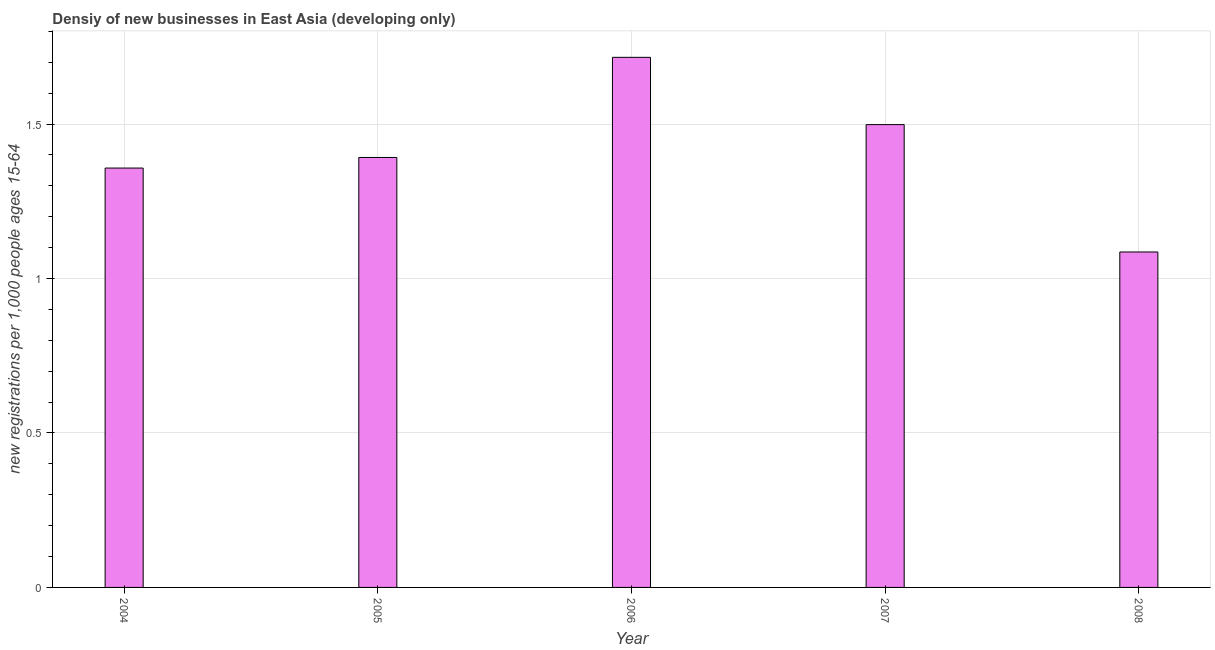Does the graph contain any zero values?
Offer a terse response. No. What is the title of the graph?
Ensure brevity in your answer.  Densiy of new businesses in East Asia (developing only). What is the label or title of the X-axis?
Give a very brief answer. Year. What is the label or title of the Y-axis?
Provide a succinct answer. New registrations per 1,0 people ages 15-64. What is the density of new business in 2004?
Your response must be concise. 1.36. Across all years, what is the maximum density of new business?
Your answer should be compact. 1.72. Across all years, what is the minimum density of new business?
Your response must be concise. 1.09. In which year was the density of new business maximum?
Give a very brief answer. 2006. What is the sum of the density of new business?
Provide a short and direct response. 7.05. What is the difference between the density of new business in 2004 and 2006?
Ensure brevity in your answer.  -0.36. What is the average density of new business per year?
Provide a succinct answer. 1.41. What is the median density of new business?
Make the answer very short. 1.39. In how many years, is the density of new business greater than 0.7 ?
Your response must be concise. 5. Do a majority of the years between 2008 and 2006 (inclusive) have density of new business greater than 1.4 ?
Ensure brevity in your answer.  Yes. What is the ratio of the density of new business in 2004 to that in 2007?
Your answer should be very brief. 0.91. Is the density of new business in 2005 less than that in 2006?
Your answer should be compact. Yes. Is the difference between the density of new business in 2006 and 2007 greater than the difference between any two years?
Provide a short and direct response. No. What is the difference between the highest and the second highest density of new business?
Keep it short and to the point. 0.22. Is the sum of the density of new business in 2004 and 2007 greater than the maximum density of new business across all years?
Offer a terse response. Yes. What is the difference between the highest and the lowest density of new business?
Give a very brief answer. 0.63. In how many years, is the density of new business greater than the average density of new business taken over all years?
Ensure brevity in your answer.  2. Are all the bars in the graph horizontal?
Give a very brief answer. No. What is the difference between two consecutive major ticks on the Y-axis?
Offer a very short reply. 0.5. What is the new registrations per 1,000 people ages 15-64 of 2004?
Your answer should be very brief. 1.36. What is the new registrations per 1,000 people ages 15-64 of 2005?
Give a very brief answer. 1.39. What is the new registrations per 1,000 people ages 15-64 in 2006?
Your response must be concise. 1.72. What is the new registrations per 1,000 people ages 15-64 of 2007?
Your answer should be compact. 1.5. What is the new registrations per 1,000 people ages 15-64 of 2008?
Offer a very short reply. 1.09. What is the difference between the new registrations per 1,000 people ages 15-64 in 2004 and 2005?
Your answer should be compact. -0.03. What is the difference between the new registrations per 1,000 people ages 15-64 in 2004 and 2006?
Your response must be concise. -0.36. What is the difference between the new registrations per 1,000 people ages 15-64 in 2004 and 2007?
Offer a very short reply. -0.14. What is the difference between the new registrations per 1,000 people ages 15-64 in 2004 and 2008?
Ensure brevity in your answer.  0.27. What is the difference between the new registrations per 1,000 people ages 15-64 in 2005 and 2006?
Your response must be concise. -0.32. What is the difference between the new registrations per 1,000 people ages 15-64 in 2005 and 2007?
Ensure brevity in your answer.  -0.11. What is the difference between the new registrations per 1,000 people ages 15-64 in 2005 and 2008?
Provide a succinct answer. 0.31. What is the difference between the new registrations per 1,000 people ages 15-64 in 2006 and 2007?
Offer a very short reply. 0.22. What is the difference between the new registrations per 1,000 people ages 15-64 in 2006 and 2008?
Offer a very short reply. 0.63. What is the difference between the new registrations per 1,000 people ages 15-64 in 2007 and 2008?
Your answer should be very brief. 0.41. What is the ratio of the new registrations per 1,000 people ages 15-64 in 2004 to that in 2005?
Your answer should be very brief. 0.97. What is the ratio of the new registrations per 1,000 people ages 15-64 in 2004 to that in 2006?
Offer a very short reply. 0.79. What is the ratio of the new registrations per 1,000 people ages 15-64 in 2004 to that in 2007?
Make the answer very short. 0.91. What is the ratio of the new registrations per 1,000 people ages 15-64 in 2004 to that in 2008?
Give a very brief answer. 1.25. What is the ratio of the new registrations per 1,000 people ages 15-64 in 2005 to that in 2006?
Offer a very short reply. 0.81. What is the ratio of the new registrations per 1,000 people ages 15-64 in 2005 to that in 2007?
Offer a terse response. 0.93. What is the ratio of the new registrations per 1,000 people ages 15-64 in 2005 to that in 2008?
Your answer should be compact. 1.28. What is the ratio of the new registrations per 1,000 people ages 15-64 in 2006 to that in 2007?
Provide a succinct answer. 1.15. What is the ratio of the new registrations per 1,000 people ages 15-64 in 2006 to that in 2008?
Offer a very short reply. 1.58. What is the ratio of the new registrations per 1,000 people ages 15-64 in 2007 to that in 2008?
Your answer should be compact. 1.38. 